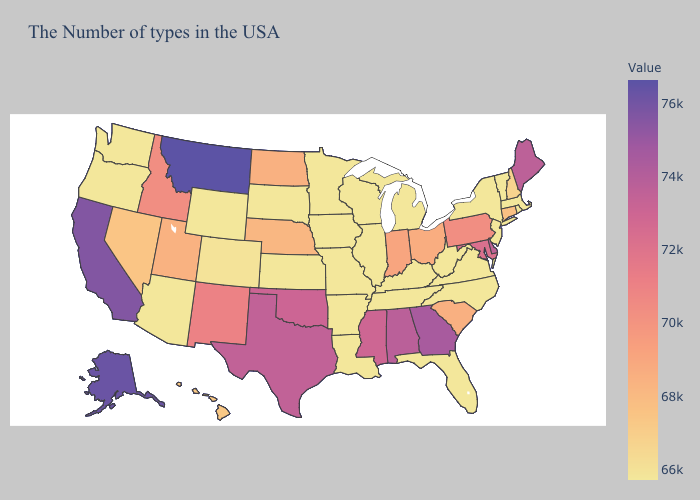Does Alabama have a lower value than Oregon?
Quick response, please. No. Does Maryland have the highest value in the USA?
Give a very brief answer. No. Among the states that border Vermont , which have the highest value?
Write a very short answer. New Hampshire. Among the states that border Kentucky , which have the lowest value?
Answer briefly. Virginia, West Virginia, Tennessee, Illinois, Missouri. Is the legend a continuous bar?
Short answer required. Yes. Does Georgia have the lowest value in the USA?
Be succinct. No. 